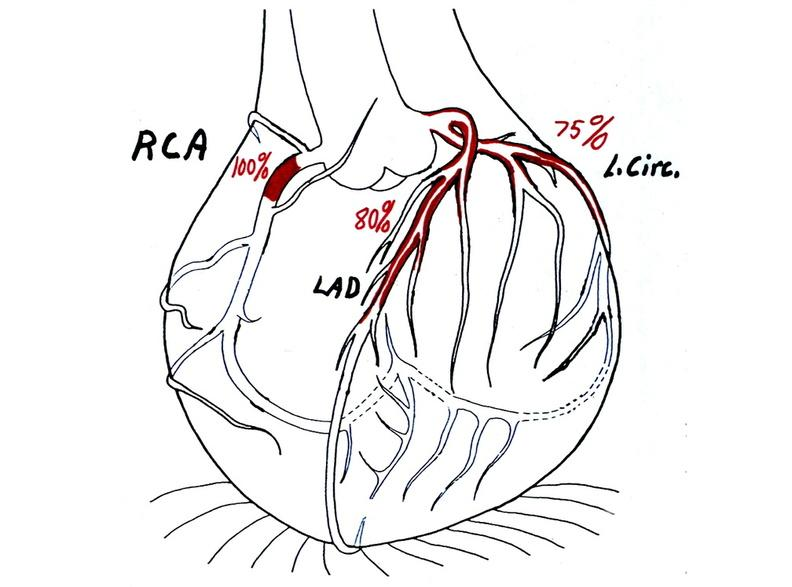does slide show coronary artery atherosclerosis diagram?
Answer the question using a single word or phrase. No 